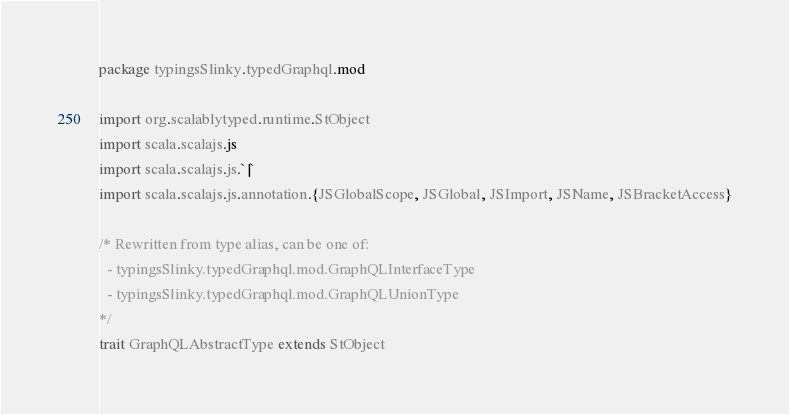<code> <loc_0><loc_0><loc_500><loc_500><_Scala_>package typingsSlinky.typedGraphql.mod

import org.scalablytyped.runtime.StObject
import scala.scalajs.js
import scala.scalajs.js.`|`
import scala.scalajs.js.annotation.{JSGlobalScope, JSGlobal, JSImport, JSName, JSBracketAccess}

/* Rewritten from type alias, can be one of: 
  - typingsSlinky.typedGraphql.mod.GraphQLInterfaceType
  - typingsSlinky.typedGraphql.mod.GraphQLUnionType
*/
trait GraphQLAbstractType extends StObject
</code> 